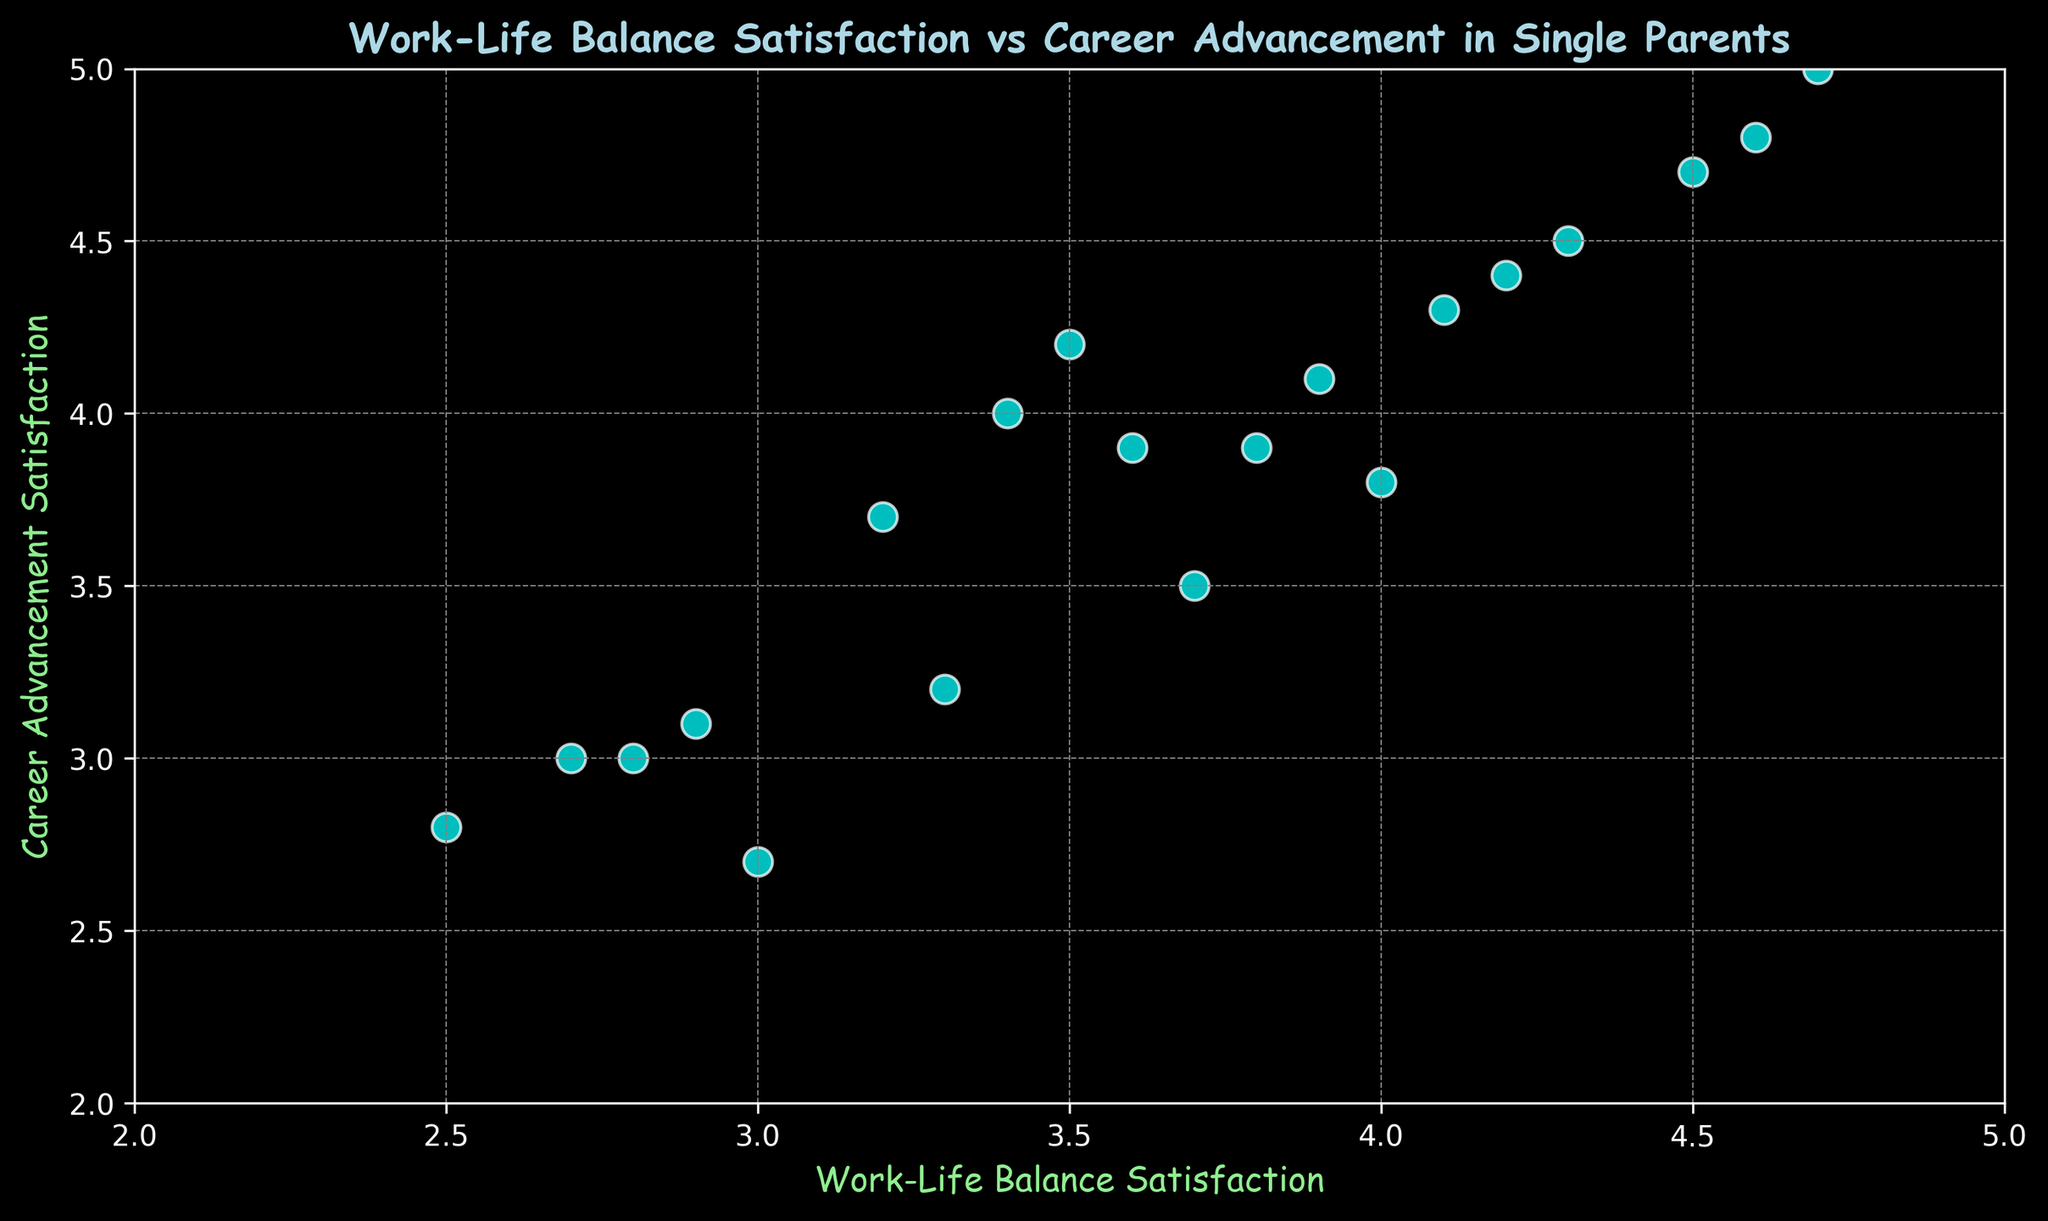What is the range of work-life balance satisfaction scores in the figure? The work-life balance satisfaction scores range from 2.5 to 4.7, as observed from the minimum and maximum points on the x-axis.
Answer: 2.5 to 4.7 Which parent has the highest career advancement satisfaction? The highest career advancement satisfaction score in the figure is 5.0, and it is for the parent with a work-life balance satisfaction score of 4.7.
Answer: Parent 7 How many parents reported a work-life balance satisfaction score above 4? By examining the points on the scatter plot, we count the number of points that fall to the right of 4 on the x-axis. There are 6 points.
Answer: 6 Is there a positive correlation between work-life balance satisfaction and career advancement satisfaction in the figure? The majority of points trend upwards from left to right, indicating that higher work-life balance satisfaction tends to correlate with higher career advancement satisfaction.
Answer: Yes What is the average career advancement satisfaction score for parents with a work-life balance satisfaction score below 3? Identify the points with work-life balance satisfaction below 3 (2.7, 2.5, 2.9, 2.8). The corresponding career advancement scores are 3.0, 2.8, 3.1, 3.0. The average is (3.0 + 2.8 + 3.1 + 3.0) / 4 = 2.975.
Answer: 2.975 Compare the career advancement satisfaction between parents with work-life balance scores of 4.1 and 4.5. The figure shows that the parent with a work-life balance score of 4.1 has a career advancement satisfaction of 4.3, while the parent with a 4.5 balance score has a 4.7 career satisfaction.
Answer: Parent with 4.5 has higher satisfaction Find the median work-life balance satisfaction score in the figure. Order all the work-life balance satisfaction scores: 2.5, 2.7, 2.8, 2.9, 3.0, 3.2, 3.3, 3.4, 3.5, 3.6, 3.7, 3.8, 3.9, 4.0, 4.1, 4.2, 4.3, 4.5, 4.6, 4.7. The median score is the average of the 10th and 11th values: (3.6 + 3.7) / 2 = 3.65.
Answer: 3.65 Which parent has the lowest work-life balance satisfaction, and what is their career advancement satisfaction? The lowest work-life balance satisfaction score is 2.5, and the corresponding career advancement satisfaction score for that parent is 2.8.
Answer: Parent 8, 2.8 What is the overall trend observed in the scatter plot? The scatter plot shows an overall positive trend, indicating that as work-life balance satisfaction increases, career advancement satisfaction also tends to increase.
Answer: Positive trend 